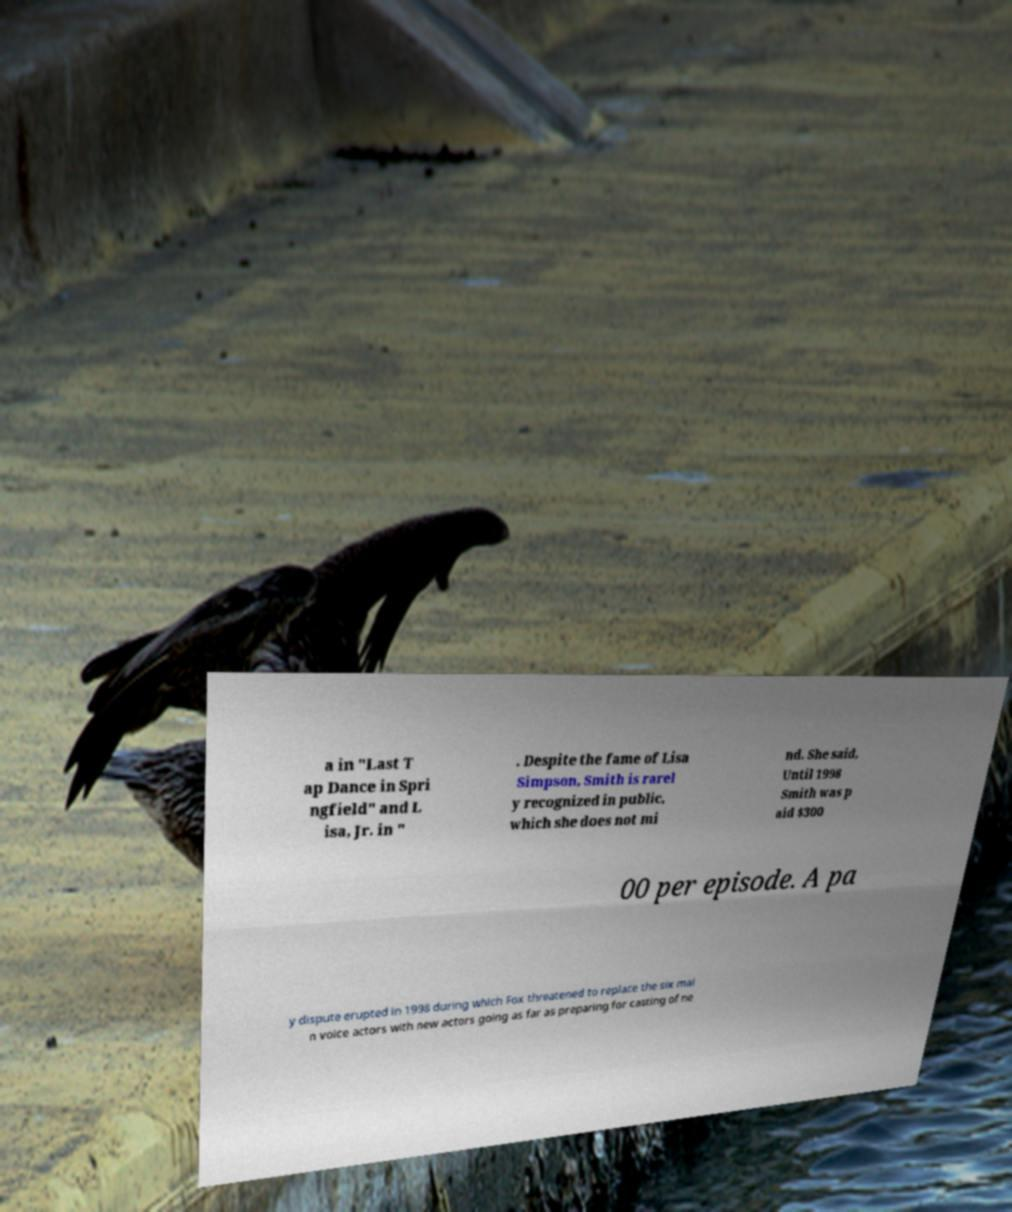For documentation purposes, I need the text within this image transcribed. Could you provide that? a in "Last T ap Dance in Spri ngfield" and L isa, Jr. in " . Despite the fame of Lisa Simpson, Smith is rarel y recognized in public, which she does not mi nd. She said, Until 1998 Smith was p aid $300 00 per episode. A pa y dispute erupted in 1998 during which Fox threatened to replace the six mai n voice actors with new actors going as far as preparing for casting of ne 